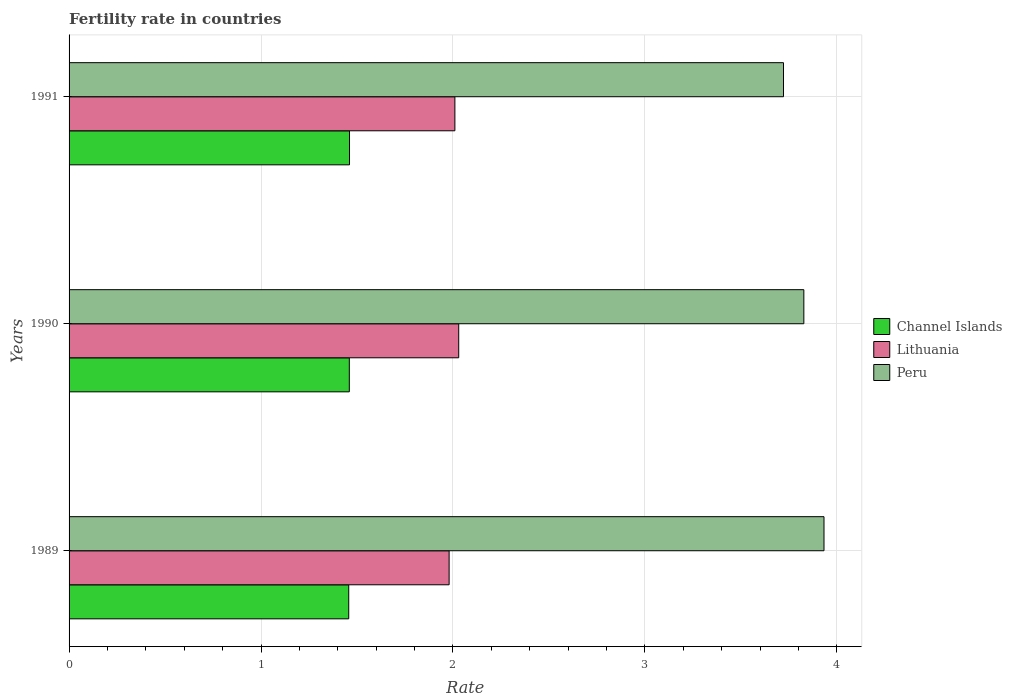How many different coloured bars are there?
Offer a very short reply. 3. Are the number of bars on each tick of the Y-axis equal?
Your response must be concise. Yes. What is the fertility rate in Lithuania in 1991?
Offer a very short reply. 2.01. Across all years, what is the maximum fertility rate in Peru?
Your answer should be compact. 3.93. Across all years, what is the minimum fertility rate in Lithuania?
Offer a very short reply. 1.98. In which year was the fertility rate in Channel Islands minimum?
Your response must be concise. 1989. What is the total fertility rate in Channel Islands in the graph?
Your response must be concise. 4.38. What is the difference between the fertility rate in Lithuania in 1989 and that in 1991?
Your answer should be compact. -0.03. What is the difference between the fertility rate in Peru in 1990 and the fertility rate in Channel Islands in 1989?
Your answer should be very brief. 2.37. What is the average fertility rate in Channel Islands per year?
Offer a terse response. 1.46. In the year 1989, what is the difference between the fertility rate in Peru and fertility rate in Channel Islands?
Provide a short and direct response. 2.48. What is the ratio of the fertility rate in Lithuania in 1989 to that in 1990?
Your response must be concise. 0.98. What is the difference between the highest and the second highest fertility rate in Peru?
Make the answer very short. 0.1. What is the difference between the highest and the lowest fertility rate in Channel Islands?
Offer a terse response. 0. In how many years, is the fertility rate in Peru greater than the average fertility rate in Peru taken over all years?
Your answer should be compact. 2. Is the sum of the fertility rate in Lithuania in 1989 and 1991 greater than the maximum fertility rate in Peru across all years?
Your answer should be very brief. Yes. What does the 2nd bar from the bottom in 1991 represents?
Provide a succinct answer. Lithuania. How many bars are there?
Provide a succinct answer. 9. How many years are there in the graph?
Ensure brevity in your answer.  3. Are the values on the major ticks of X-axis written in scientific E-notation?
Offer a very short reply. No. Does the graph contain grids?
Give a very brief answer. Yes. How many legend labels are there?
Provide a succinct answer. 3. How are the legend labels stacked?
Give a very brief answer. Vertical. What is the title of the graph?
Keep it short and to the point. Fertility rate in countries. Does "Kyrgyz Republic" appear as one of the legend labels in the graph?
Your response must be concise. No. What is the label or title of the X-axis?
Your response must be concise. Rate. What is the label or title of the Y-axis?
Offer a very short reply. Years. What is the Rate in Channel Islands in 1989?
Offer a very short reply. 1.46. What is the Rate of Lithuania in 1989?
Provide a short and direct response. 1.98. What is the Rate of Peru in 1989?
Provide a succinct answer. 3.93. What is the Rate of Channel Islands in 1990?
Give a very brief answer. 1.46. What is the Rate of Lithuania in 1990?
Your response must be concise. 2.03. What is the Rate of Peru in 1990?
Offer a terse response. 3.83. What is the Rate in Channel Islands in 1991?
Give a very brief answer. 1.46. What is the Rate of Lithuania in 1991?
Make the answer very short. 2.01. What is the Rate in Peru in 1991?
Give a very brief answer. 3.72. Across all years, what is the maximum Rate in Channel Islands?
Make the answer very short. 1.46. Across all years, what is the maximum Rate of Lithuania?
Make the answer very short. 2.03. Across all years, what is the maximum Rate of Peru?
Offer a very short reply. 3.93. Across all years, what is the minimum Rate of Channel Islands?
Offer a terse response. 1.46. Across all years, what is the minimum Rate in Lithuania?
Give a very brief answer. 1.98. Across all years, what is the minimum Rate in Peru?
Offer a terse response. 3.72. What is the total Rate of Channel Islands in the graph?
Ensure brevity in your answer.  4.38. What is the total Rate in Lithuania in the graph?
Your response must be concise. 6.02. What is the total Rate in Peru in the graph?
Your answer should be very brief. 11.48. What is the difference between the Rate in Channel Islands in 1989 and that in 1990?
Your answer should be compact. -0. What is the difference between the Rate in Peru in 1989 and that in 1990?
Give a very brief answer. 0.1. What is the difference between the Rate in Channel Islands in 1989 and that in 1991?
Provide a succinct answer. -0. What is the difference between the Rate of Lithuania in 1989 and that in 1991?
Make the answer very short. -0.03. What is the difference between the Rate in Peru in 1989 and that in 1991?
Offer a very short reply. 0.21. What is the difference between the Rate in Channel Islands in 1990 and that in 1991?
Keep it short and to the point. -0. What is the difference between the Rate of Lithuania in 1990 and that in 1991?
Keep it short and to the point. 0.02. What is the difference between the Rate of Peru in 1990 and that in 1991?
Keep it short and to the point. 0.11. What is the difference between the Rate of Channel Islands in 1989 and the Rate of Lithuania in 1990?
Offer a very short reply. -0.57. What is the difference between the Rate in Channel Islands in 1989 and the Rate in Peru in 1990?
Offer a terse response. -2.37. What is the difference between the Rate in Lithuania in 1989 and the Rate in Peru in 1990?
Your answer should be very brief. -1.85. What is the difference between the Rate in Channel Islands in 1989 and the Rate in Lithuania in 1991?
Your answer should be compact. -0.55. What is the difference between the Rate of Channel Islands in 1989 and the Rate of Peru in 1991?
Provide a succinct answer. -2.27. What is the difference between the Rate in Lithuania in 1989 and the Rate in Peru in 1991?
Your answer should be compact. -1.74. What is the difference between the Rate in Channel Islands in 1990 and the Rate in Lithuania in 1991?
Your answer should be very brief. -0.55. What is the difference between the Rate of Channel Islands in 1990 and the Rate of Peru in 1991?
Give a very brief answer. -2.26. What is the difference between the Rate of Lithuania in 1990 and the Rate of Peru in 1991?
Your response must be concise. -1.69. What is the average Rate in Channel Islands per year?
Offer a very short reply. 1.46. What is the average Rate in Lithuania per year?
Ensure brevity in your answer.  2.01. What is the average Rate in Peru per year?
Your answer should be compact. 3.83. In the year 1989, what is the difference between the Rate in Channel Islands and Rate in Lithuania?
Your response must be concise. -0.52. In the year 1989, what is the difference between the Rate in Channel Islands and Rate in Peru?
Give a very brief answer. -2.48. In the year 1989, what is the difference between the Rate of Lithuania and Rate of Peru?
Your response must be concise. -1.95. In the year 1990, what is the difference between the Rate of Channel Islands and Rate of Lithuania?
Offer a very short reply. -0.57. In the year 1990, what is the difference between the Rate in Channel Islands and Rate in Peru?
Ensure brevity in your answer.  -2.37. In the year 1990, what is the difference between the Rate in Lithuania and Rate in Peru?
Make the answer very short. -1.8. In the year 1991, what is the difference between the Rate in Channel Islands and Rate in Lithuania?
Give a very brief answer. -0.55. In the year 1991, what is the difference between the Rate in Channel Islands and Rate in Peru?
Your answer should be very brief. -2.26. In the year 1991, what is the difference between the Rate of Lithuania and Rate of Peru?
Your response must be concise. -1.71. What is the ratio of the Rate in Channel Islands in 1989 to that in 1990?
Offer a terse response. 1. What is the ratio of the Rate in Lithuania in 1989 to that in 1990?
Keep it short and to the point. 0.98. What is the ratio of the Rate in Peru in 1989 to that in 1990?
Give a very brief answer. 1.03. What is the ratio of the Rate in Channel Islands in 1989 to that in 1991?
Give a very brief answer. 1. What is the ratio of the Rate of Lithuania in 1989 to that in 1991?
Offer a terse response. 0.99. What is the ratio of the Rate of Peru in 1989 to that in 1991?
Provide a short and direct response. 1.06. What is the ratio of the Rate of Lithuania in 1990 to that in 1991?
Provide a short and direct response. 1.01. What is the ratio of the Rate of Peru in 1990 to that in 1991?
Give a very brief answer. 1.03. What is the difference between the highest and the second highest Rate of Channel Islands?
Offer a terse response. 0. What is the difference between the highest and the second highest Rate in Peru?
Offer a very short reply. 0.1. What is the difference between the highest and the lowest Rate in Channel Islands?
Your answer should be compact. 0. What is the difference between the highest and the lowest Rate of Lithuania?
Give a very brief answer. 0.05. What is the difference between the highest and the lowest Rate in Peru?
Keep it short and to the point. 0.21. 